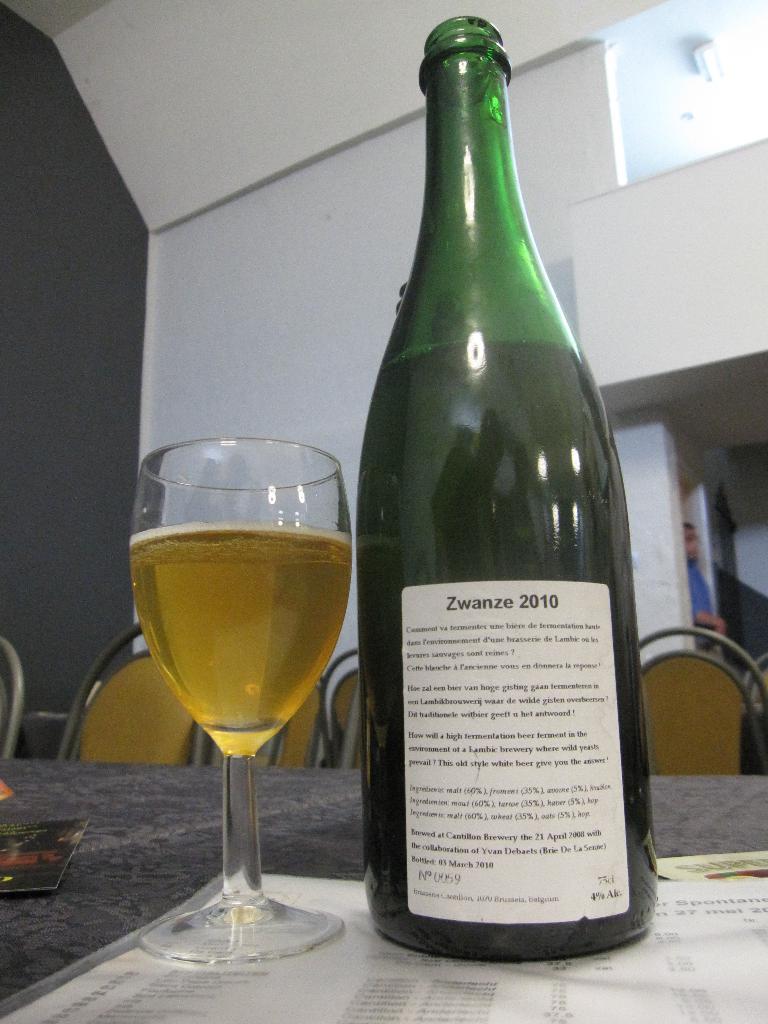In one or two sentences, can you explain what this image depicts? In this image I can see a bottle, a glass and few chairs. I can also see a person. 